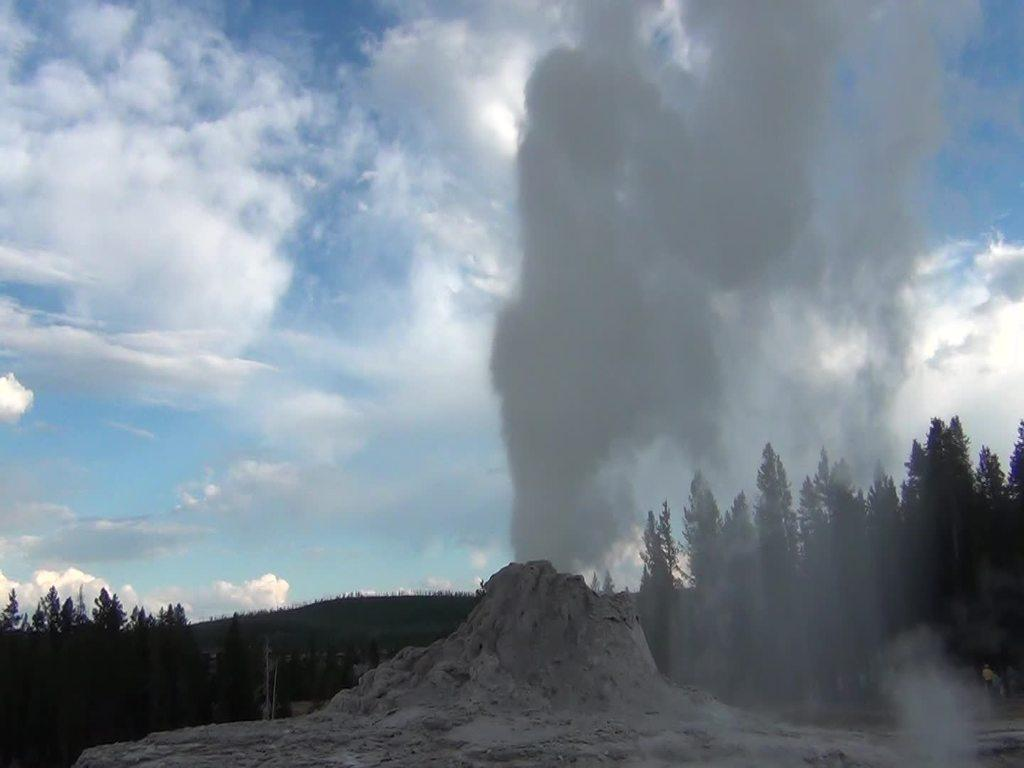What type of vegetation can be seen in the image? There are trees in the image. What can be seen rising from the ground in the image? There is smoke visible in the image. What type of terrain is present in the image? There is sand in the image. What is the condition of the sky in the image? The sky is cloudy in the image. What type of part is being produced in the image? There is no reference to a part or production in the image; it features trees, smoke, sand, and a cloudy sky. What is the expression of love shown in the image? There is no expression of love depicted in the image. 